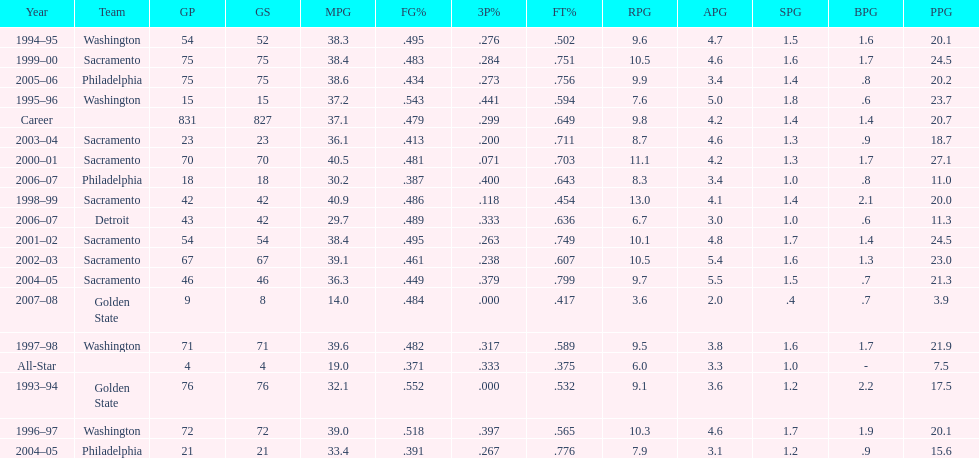How many seasons did webber average over 20 points per game (ppg)? 11. 